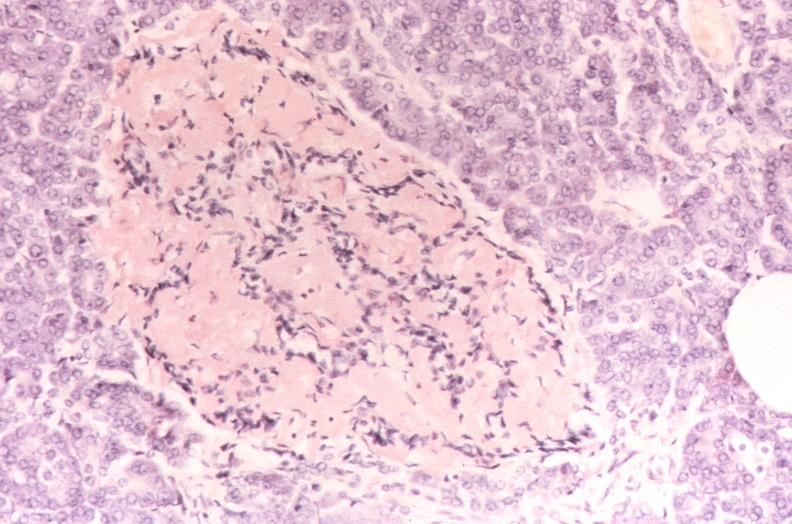does 70yof stain?
Answer the question using a single word or phrase. No 